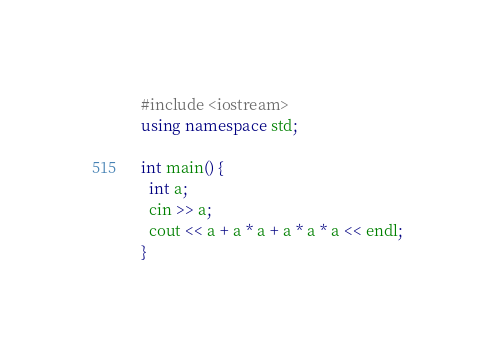Convert code to text. <code><loc_0><loc_0><loc_500><loc_500><_C++_>#include <iostream>
using namespace std;

int main() {
  int a;
  cin >> a;
  cout << a + a * a + a * a * a << endl;
}</code> 